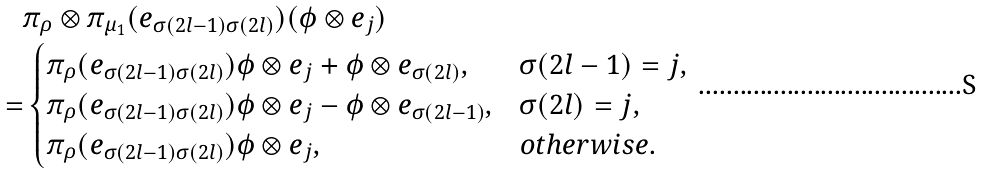Convert formula to latex. <formula><loc_0><loc_0><loc_500><loc_500>& \pi _ { \rho } \otimes \pi _ { \mu _ { 1 } } ( e _ { \sigma ( 2 l - 1 ) \sigma ( 2 l ) } ) ( \phi \otimes e _ { j } ) \\ = & \begin{cases} \pi _ { \rho } ( e _ { \sigma ( 2 l - 1 ) \sigma ( 2 l ) } ) \phi \otimes e _ { j } + \phi \otimes e _ { \sigma ( 2 l ) } , & \sigma ( 2 l - 1 ) = j , \\ \pi _ { \rho } ( e _ { \sigma ( 2 l - 1 ) \sigma ( 2 l ) } ) \phi \otimes e _ { j } - \phi \otimes e _ { \sigma ( 2 l - 1 ) } , & \sigma ( 2 l ) = j , \\ \pi _ { \rho } ( e _ { \sigma ( 2 l - 1 ) \sigma ( 2 l ) } ) \phi \otimes e _ { j } , & o t h e r w i s e . \end{cases}</formula> 